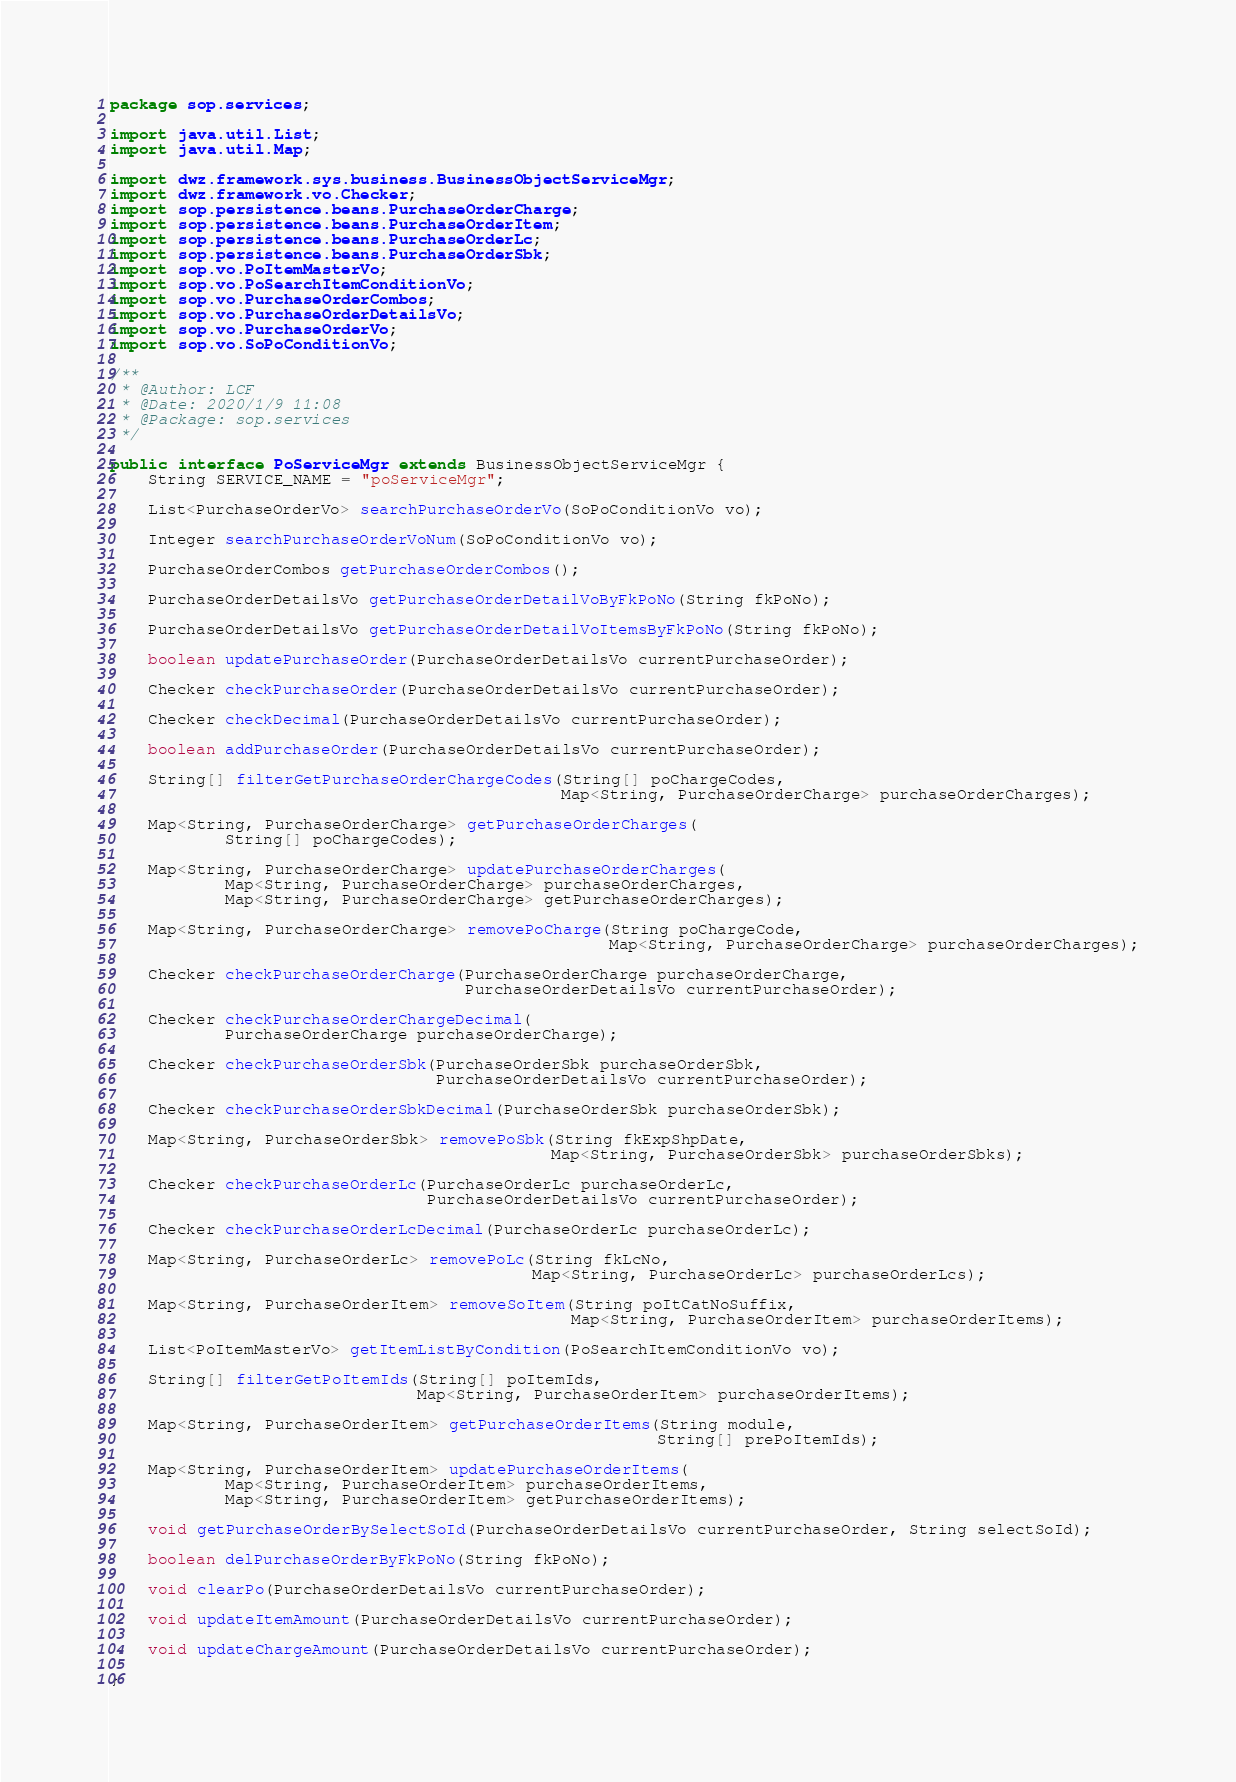Convert code to text. <code><loc_0><loc_0><loc_500><loc_500><_Java_>package sop.services;

import java.util.List;
import java.util.Map;

import dwz.framework.sys.business.BusinessObjectServiceMgr;
import dwz.framework.vo.Checker;
import sop.persistence.beans.PurchaseOrderCharge;
import sop.persistence.beans.PurchaseOrderItem;
import sop.persistence.beans.PurchaseOrderLc;
import sop.persistence.beans.PurchaseOrderSbk;
import sop.vo.PoItemMasterVo;
import sop.vo.PoSearchItemConditionVo;
import sop.vo.PurchaseOrderCombos;
import sop.vo.PurchaseOrderDetailsVo;
import sop.vo.PurchaseOrderVo;
import sop.vo.SoPoConditionVo;

/**
 * @Author: LCF
 * @Date: 2020/1/9 11:08
 * @Package: sop.services
 */

public interface PoServiceMgr extends BusinessObjectServiceMgr {
    String SERVICE_NAME = "poServiceMgr";

    List<PurchaseOrderVo> searchPurchaseOrderVo(SoPoConditionVo vo);

    Integer searchPurchaseOrderVoNum(SoPoConditionVo vo);

    PurchaseOrderCombos getPurchaseOrderCombos();

    PurchaseOrderDetailsVo getPurchaseOrderDetailVoByFkPoNo(String fkPoNo);

    PurchaseOrderDetailsVo getPurchaseOrderDetailVoItemsByFkPoNo(String fkPoNo);

    boolean updatePurchaseOrder(PurchaseOrderDetailsVo currentPurchaseOrder);

    Checker checkPurchaseOrder(PurchaseOrderDetailsVo currentPurchaseOrder);

    Checker checkDecimal(PurchaseOrderDetailsVo currentPurchaseOrder);

    boolean addPurchaseOrder(PurchaseOrderDetailsVo currentPurchaseOrder);

    String[] filterGetPurchaseOrderChargeCodes(String[] poChargeCodes,
                                               Map<String, PurchaseOrderCharge> purchaseOrderCharges);

    Map<String, PurchaseOrderCharge> getPurchaseOrderCharges(
            String[] poChargeCodes);

    Map<String, PurchaseOrderCharge> updatePurchaseOrderCharges(
            Map<String, PurchaseOrderCharge> purchaseOrderCharges,
            Map<String, PurchaseOrderCharge> getPurchaseOrderCharges);

    Map<String, PurchaseOrderCharge> removePoCharge(String poChargeCode,
                                                    Map<String, PurchaseOrderCharge> purchaseOrderCharges);

    Checker checkPurchaseOrderCharge(PurchaseOrderCharge purchaseOrderCharge,
                                     PurchaseOrderDetailsVo currentPurchaseOrder);

    Checker checkPurchaseOrderChargeDecimal(
            PurchaseOrderCharge purchaseOrderCharge);

    Checker checkPurchaseOrderSbk(PurchaseOrderSbk purchaseOrderSbk,
                                  PurchaseOrderDetailsVo currentPurchaseOrder);

    Checker checkPurchaseOrderSbkDecimal(PurchaseOrderSbk purchaseOrderSbk);

    Map<String, PurchaseOrderSbk> removePoSbk(String fkExpShpDate,
                                              Map<String, PurchaseOrderSbk> purchaseOrderSbks);

    Checker checkPurchaseOrderLc(PurchaseOrderLc purchaseOrderLc,
                                 PurchaseOrderDetailsVo currentPurchaseOrder);

    Checker checkPurchaseOrderLcDecimal(PurchaseOrderLc purchaseOrderLc);

    Map<String, PurchaseOrderLc> removePoLc(String fkLcNo,
                                            Map<String, PurchaseOrderLc> purchaseOrderLcs);

    Map<String, PurchaseOrderItem> removeSoItem(String poItCatNoSuffix,
                                                Map<String, PurchaseOrderItem> purchaseOrderItems);

    List<PoItemMasterVo> getItemListByCondition(PoSearchItemConditionVo vo);

    String[] filterGetPoItemIds(String[] poItemIds,
                                Map<String, PurchaseOrderItem> purchaseOrderItems);

    Map<String, PurchaseOrderItem> getPurchaseOrderItems(String module,
                                                         String[] prePoItemIds);

    Map<String, PurchaseOrderItem> updatePurchaseOrderItems(
            Map<String, PurchaseOrderItem> purchaseOrderItems,
            Map<String, PurchaseOrderItem> getPurchaseOrderItems);

    void getPurchaseOrderBySelectSoId(PurchaseOrderDetailsVo currentPurchaseOrder, String selectSoId);

    boolean delPurchaseOrderByFkPoNo(String fkPoNo);

    void clearPo(PurchaseOrderDetailsVo currentPurchaseOrder);

    void updateItemAmount(PurchaseOrderDetailsVo currentPurchaseOrder);

    void updateChargeAmount(PurchaseOrderDetailsVo currentPurchaseOrder);

}
</code> 